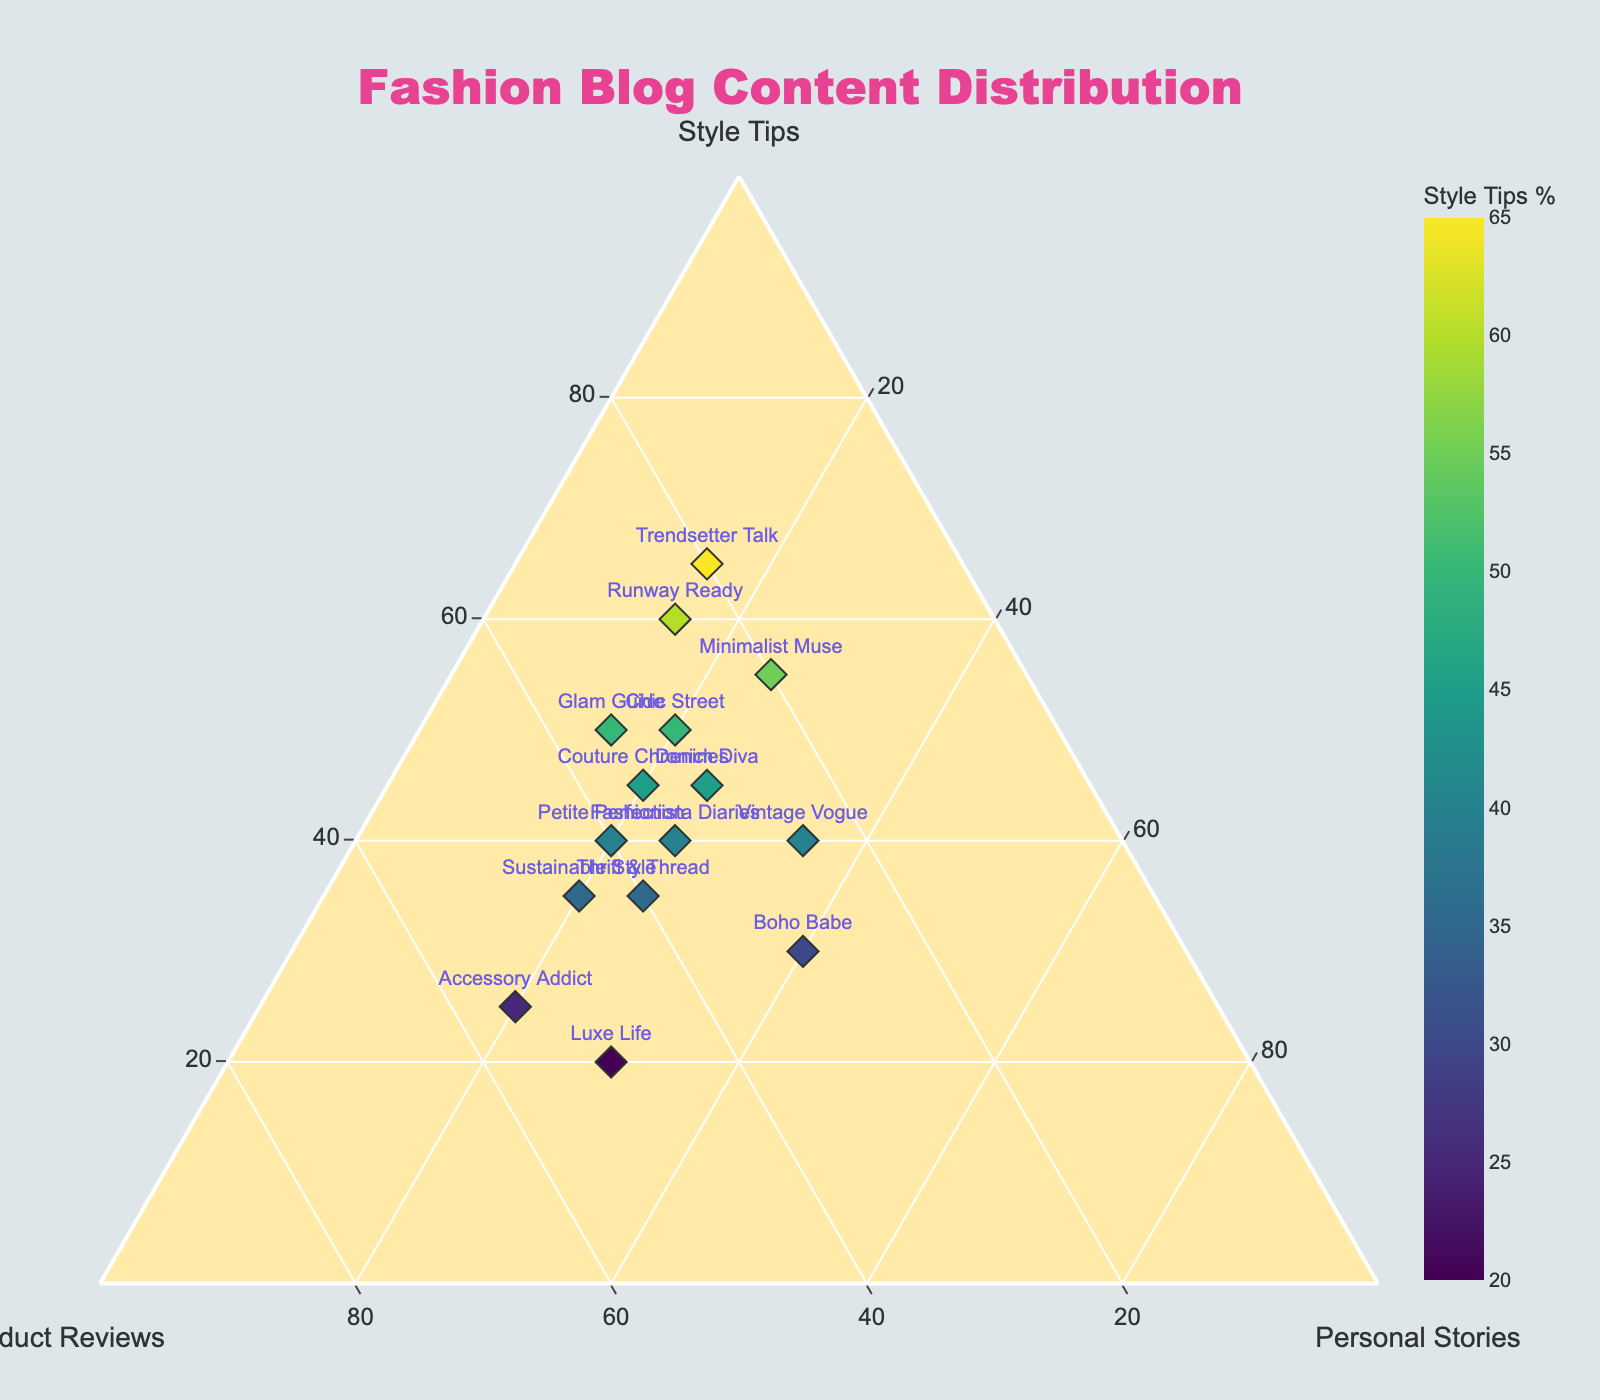How many fashion blogs are shown in the plot? Count the number of different data points (blog names) that are visible on the plot.
Answer: 15 What is the title of the ternary plot? Look at the top of the plot where the title is displayed.
Answer: Fashion Blog Content Distribution Which blog focuses the most on product reviews? Identify the data point that has the highest percentage on the 'Product Reviews' axis.
Answer: Accessory Addict What is the blog with the least focus on personal stories? Identify the data point nearest to the 'Personal Stories' axis, indicating the smallest percentage in this category.
Answer: Runway Ready, Trendsetter Talk Which two blogs have the same percentage distribution of content types? Compare the percentages of all blogs and identify if there are any pairs with matching distributions.
Answer: None Which blog has the most balanced distribution across all content types? Look for the data point closest to the center of the ternary plot, indicating equal distribution among the three content types.
Answer: Boho Babe What is the average percentage of style tips across all blogs? Sum all the percentages for style tips from each blog and divide by the number of blogs. Explanation: (50+40+60+35+45+30+55+40+20+35+65+25+45+50+40) / 15 = 43.
Answer: 43% Which category has the highest average percentage among all blogs? Calculate the average percentage for each content type (Style Tips, Product Reviews, and Personal Stories) across all blogs and compare them. Explanation: (Style Tips: 43, Product Reviews: 34, Personal Stories: 23)
Answer: Style Tips Is there a blog that has equal percentages of Style Tips and Personal Stories? Look for the data point where the value for Style Tips and Personal Stories are the same.
Answer: Boho Babe Which blog appears closest to the lower right corner of the plot? Identify the blog positioned near the 'Personal Stories' axis and the intersection of 'Product Reviews' and 'Style Tips' axes.
Answer: Luxe Life 